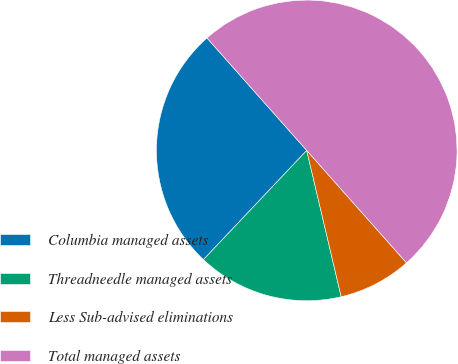Convert chart to OTSL. <chart><loc_0><loc_0><loc_500><loc_500><pie_chart><fcel>Columbia managed assets<fcel>Threadneedle managed assets<fcel>Less Sub-advised eliminations<fcel>Total managed assets<nl><fcel>26.39%<fcel>15.74%<fcel>7.87%<fcel>50.0%<nl></chart> 